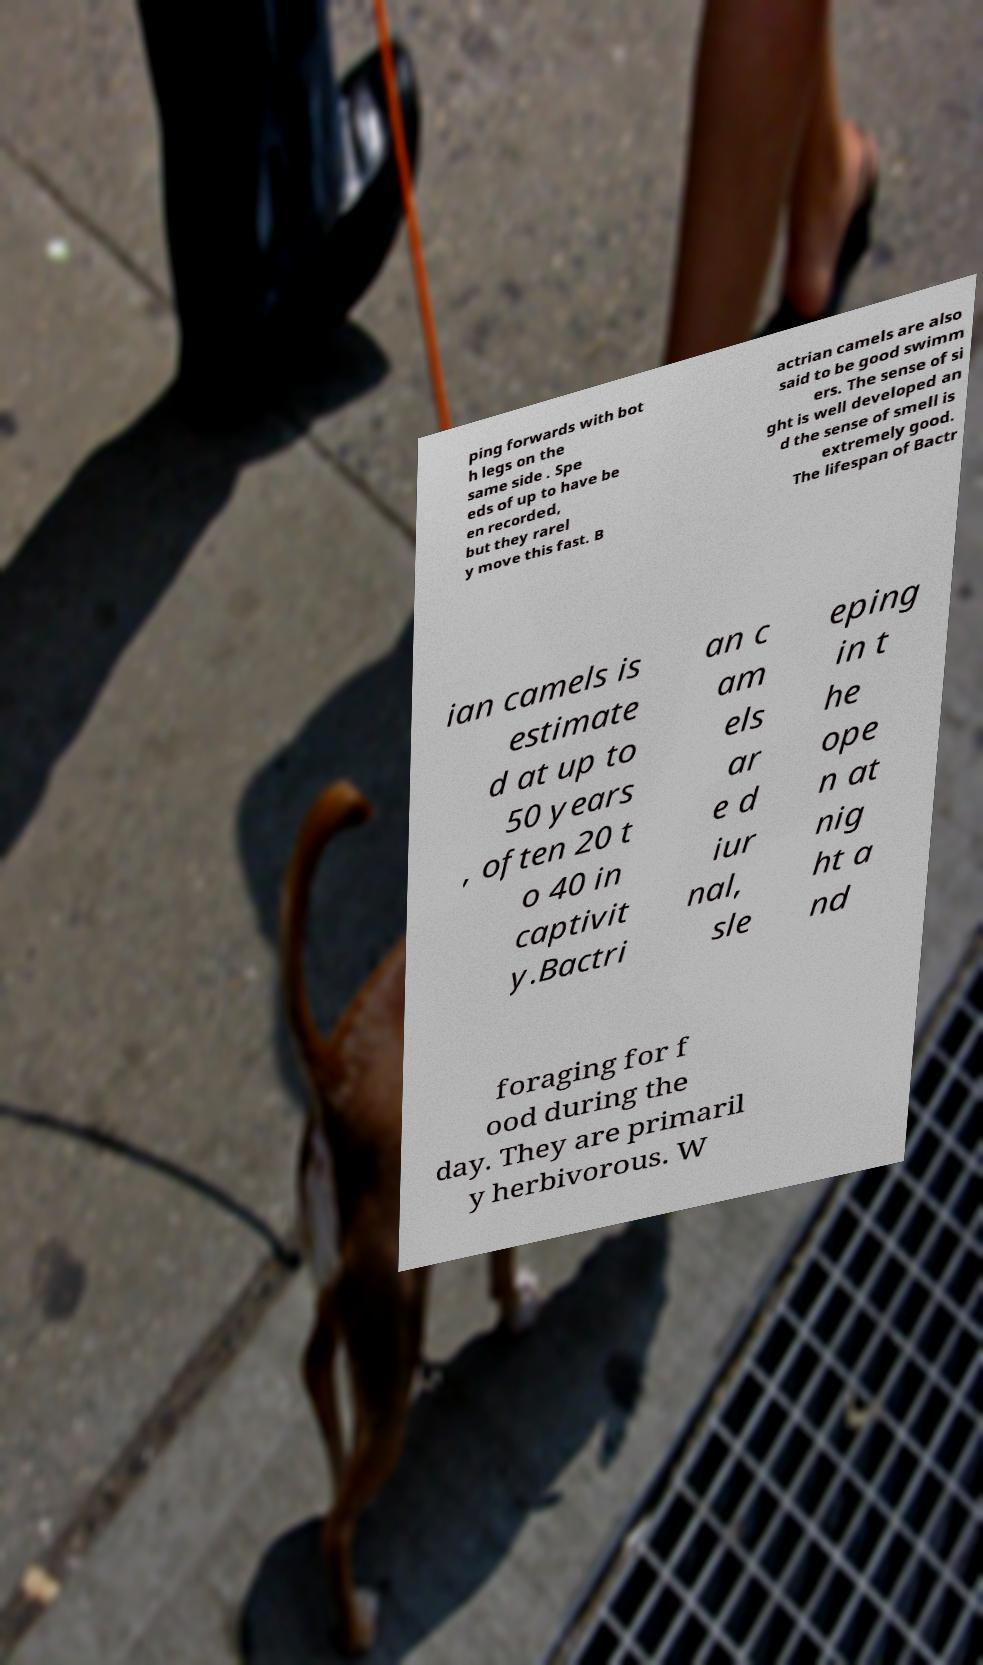Please read and relay the text visible in this image. What does it say? ping forwards with bot h legs on the same side . Spe eds of up to have be en recorded, but they rarel y move this fast. B actrian camels are also said to be good swimm ers. The sense of si ght is well developed an d the sense of smell is extremely good. The lifespan of Bactr ian camels is estimate d at up to 50 years , often 20 t o 40 in captivit y.Bactri an c am els ar e d iur nal, sle eping in t he ope n at nig ht a nd foraging for f ood during the day. They are primaril y herbivorous. W 